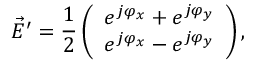Convert formula to latex. <formula><loc_0><loc_0><loc_500><loc_500>\vec { E } ^ { \prime } = \frac { 1 } { 2 } \left ( \begin{array} { l } { e ^ { j \varphi _ { x } } + e ^ { j \varphi _ { y } } } \\ { e ^ { j \varphi _ { x } } - e ^ { j \varphi _ { y } } } \end{array} \right ) ,</formula> 